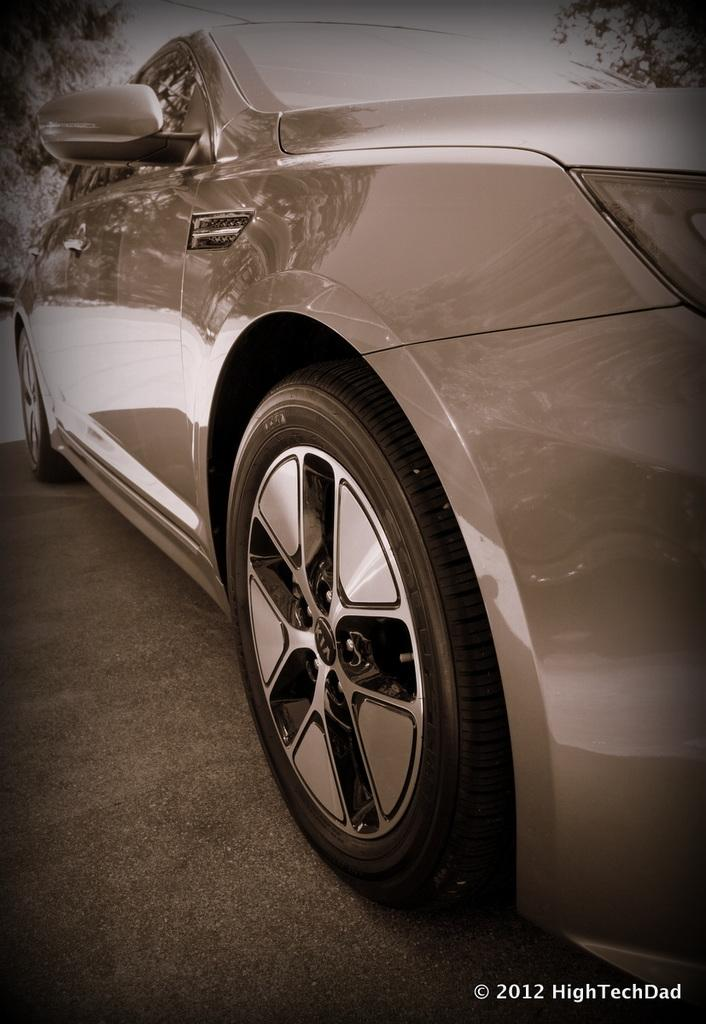What is the main subject of the image? The main subject of the image is a car on the road. What can be seen on either side of the road in the image? There are trees on either side of the road in the image. Is there any text or image in the image? Yes, there is text or an image in the right bottom corner of the image. Can you see a bee flying near the car in the image? No, there is no bee visible in the image. Is there a plane flying above the car in the image? No, there is no plane visible in the image. 